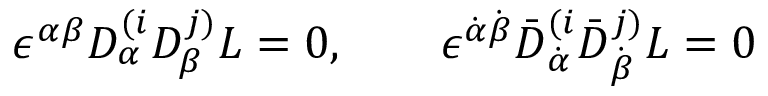<formula> <loc_0><loc_0><loc_500><loc_500>\epsilon ^ { \alpha \beta } D _ { \alpha } ^ { ( i } D _ { \beta } ^ { j ) } L = 0 , \quad \epsilon ^ { \dot { \alpha } \dot { \beta } } \bar { D } _ { \dot { \alpha } } ^ { ( i } \bar { D } _ { \dot { \beta } } ^ { j ) } L = 0</formula> 